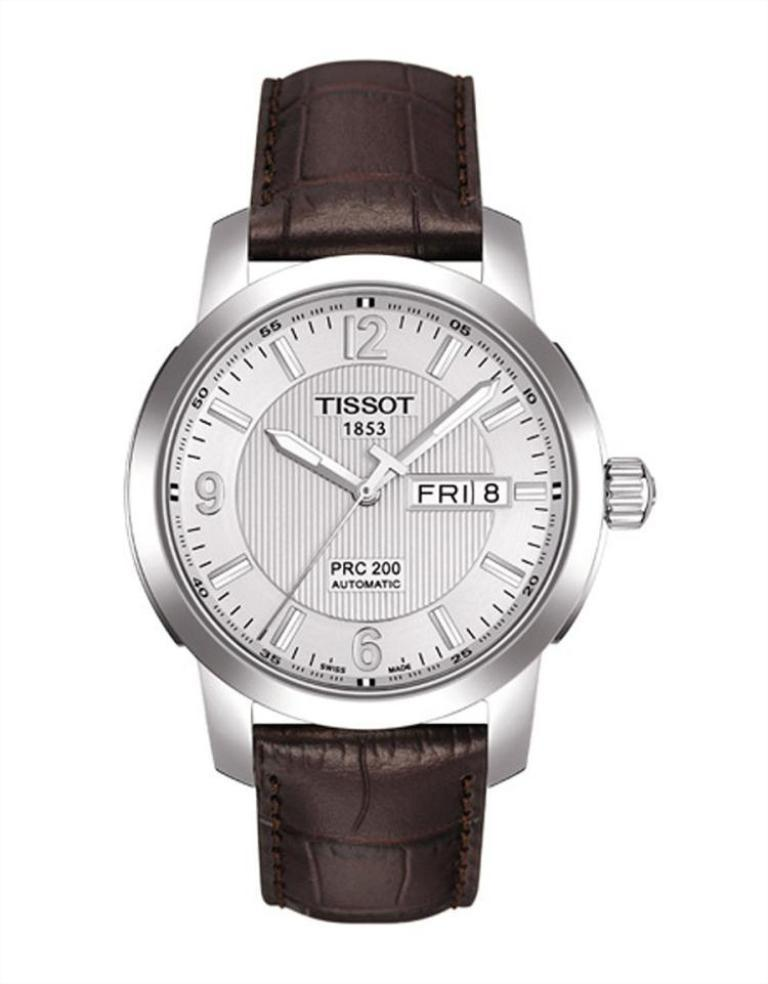<image>
Offer a succinct explanation of the picture presented. A Tissot 1853 watch that is all silver and a black band. 